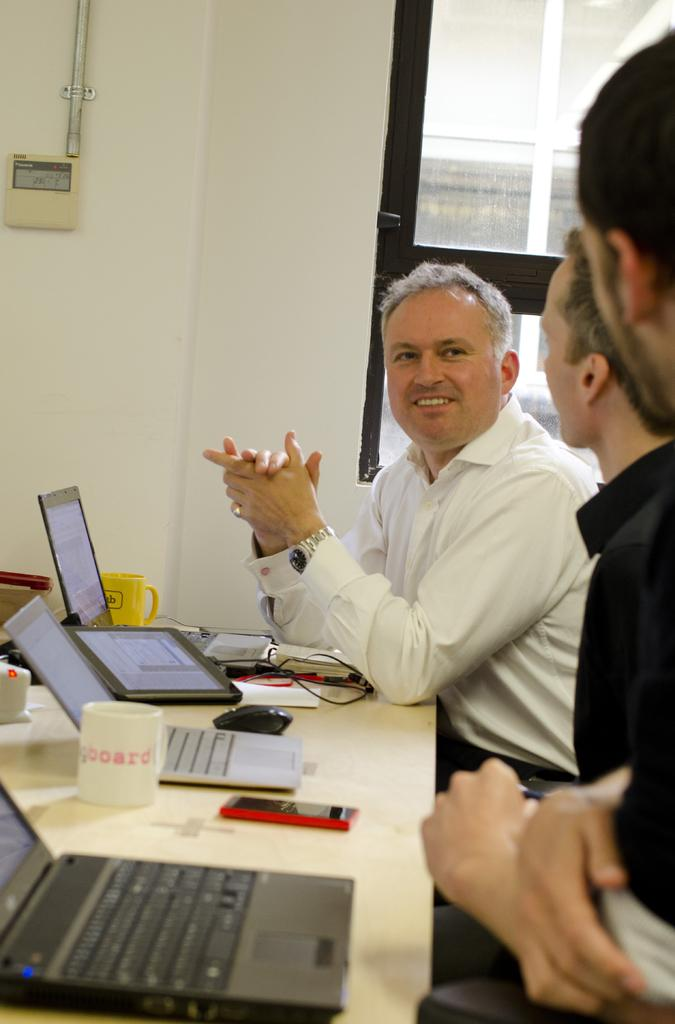<image>
Share a concise interpretation of the image provided. Three people chat in an office at  table where a mug has the word board on it. 